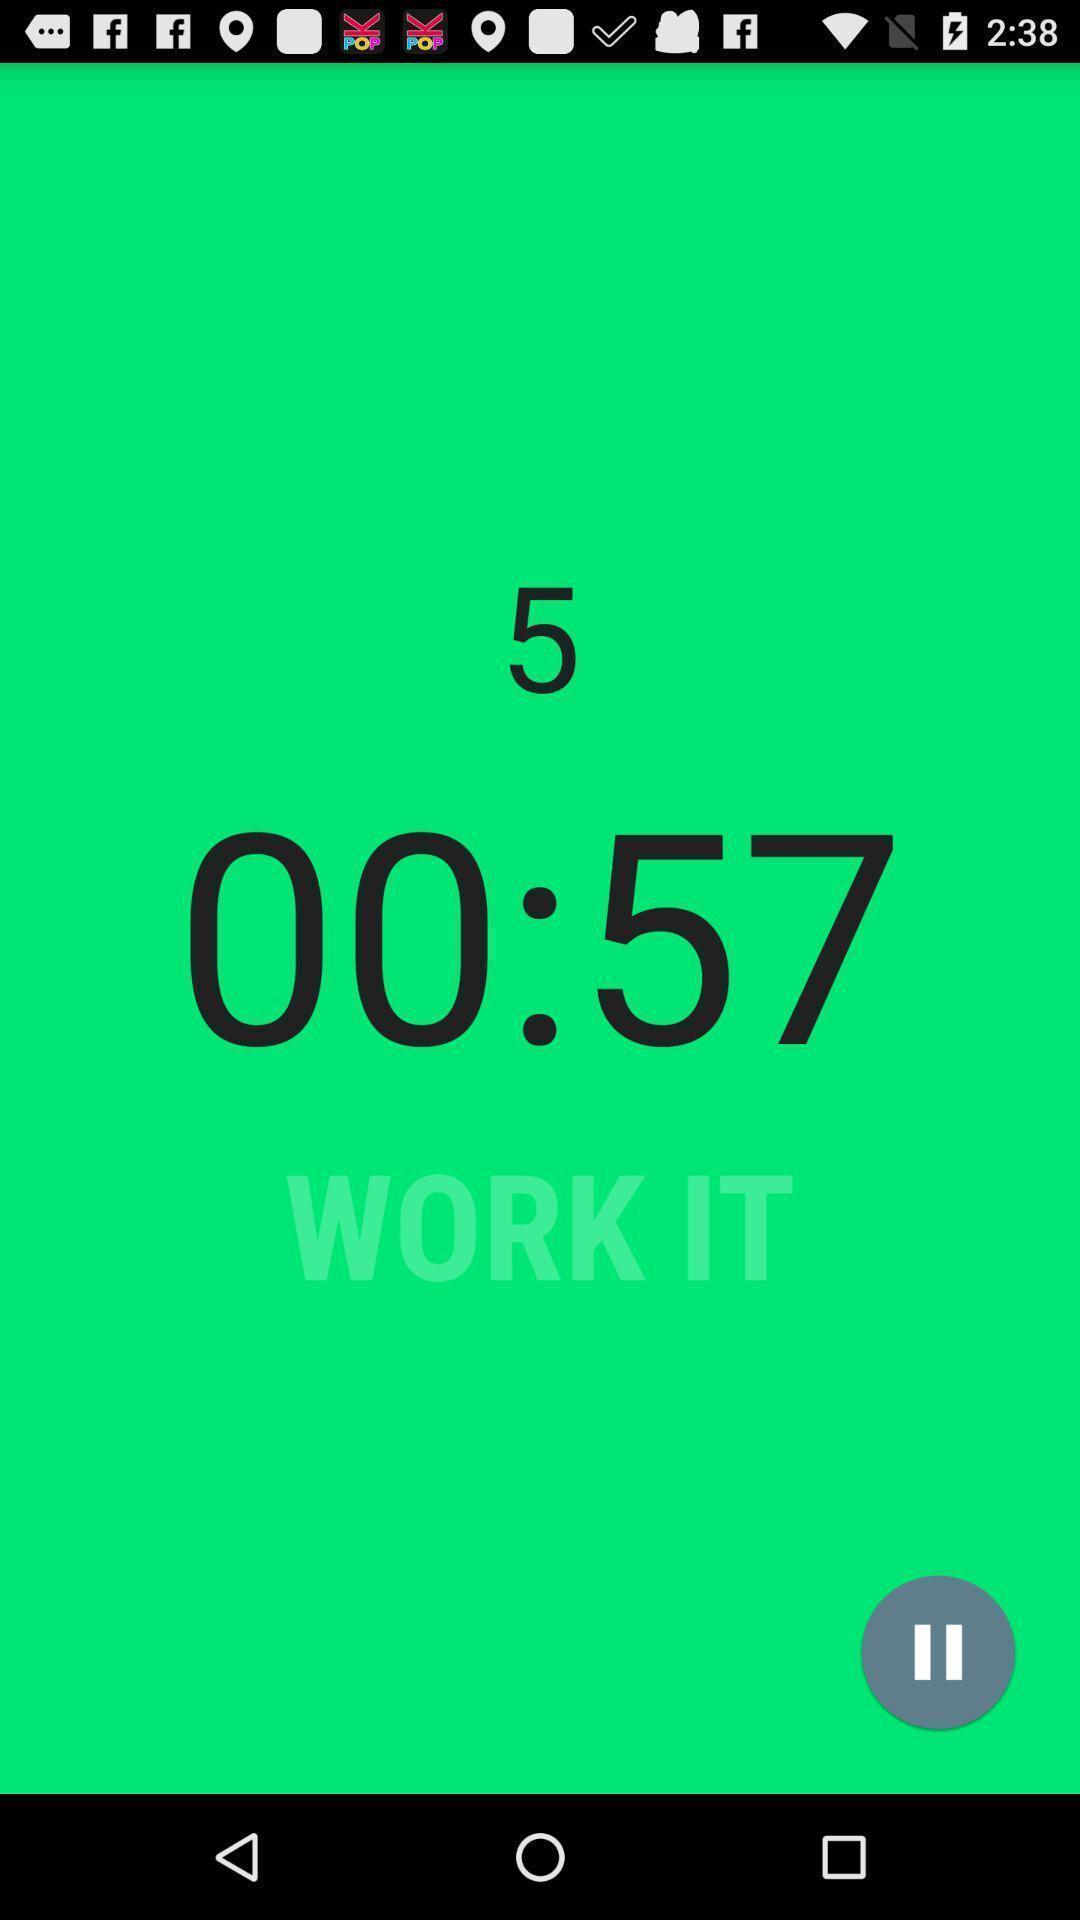Describe this image in words. Time running in a fitness app. 